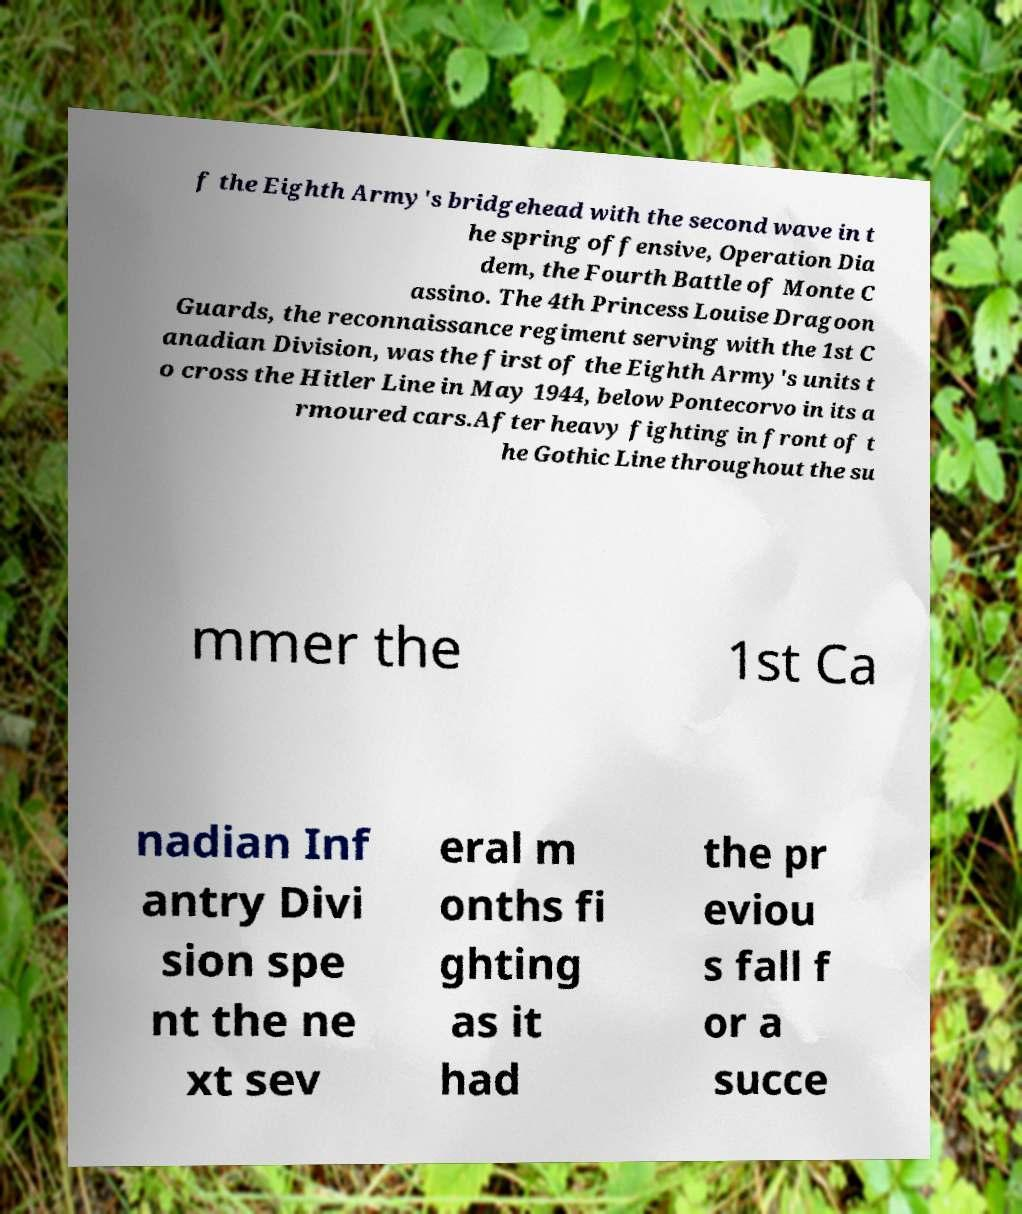Can you read and provide the text displayed in the image?This photo seems to have some interesting text. Can you extract and type it out for me? f the Eighth Army's bridgehead with the second wave in t he spring offensive, Operation Dia dem, the Fourth Battle of Monte C assino. The 4th Princess Louise Dragoon Guards, the reconnaissance regiment serving with the 1st C anadian Division, was the first of the Eighth Army's units t o cross the Hitler Line in May 1944, below Pontecorvo in its a rmoured cars.After heavy fighting in front of t he Gothic Line throughout the su mmer the 1st Ca nadian Inf antry Divi sion spe nt the ne xt sev eral m onths fi ghting as it had the pr eviou s fall f or a succe 